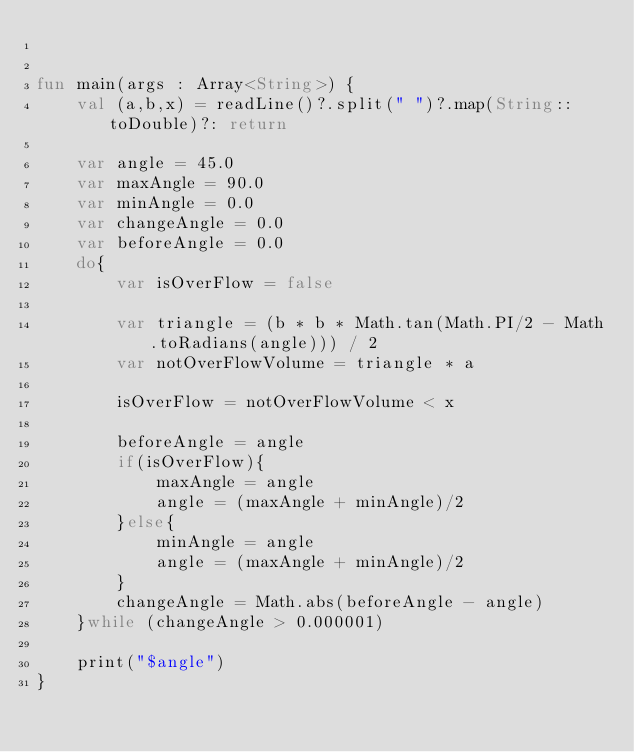<code> <loc_0><loc_0><loc_500><loc_500><_Kotlin_>

fun main(args : Array<String>) {
    val (a,b,x) = readLine()?.split(" ")?.map(String::toDouble)?: return

    var angle = 45.0
    var maxAngle = 90.0
    var minAngle = 0.0
    var changeAngle = 0.0
    var beforeAngle = 0.0
    do{
        var isOverFlow = false

        var triangle = (b * b * Math.tan(Math.PI/2 - Math.toRadians(angle))) / 2
        var notOverFlowVolume = triangle * a

        isOverFlow = notOverFlowVolume < x

        beforeAngle = angle
        if(isOverFlow){
            maxAngle = angle
            angle = (maxAngle + minAngle)/2
        }else{
            minAngle = angle
            angle = (maxAngle + minAngle)/2
        }
        changeAngle = Math.abs(beforeAngle - angle)
    }while (changeAngle > 0.000001)

    print("$angle")
}</code> 